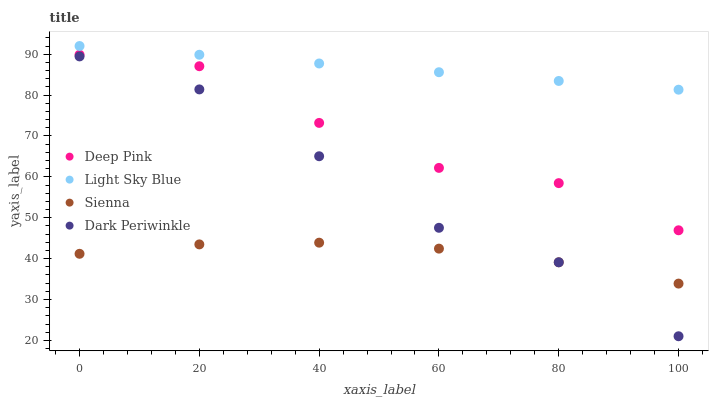Does Sienna have the minimum area under the curve?
Answer yes or no. Yes. Does Light Sky Blue have the maximum area under the curve?
Answer yes or no. Yes. Does Deep Pink have the minimum area under the curve?
Answer yes or no. No. Does Deep Pink have the maximum area under the curve?
Answer yes or no. No. Is Light Sky Blue the smoothest?
Answer yes or no. Yes. Is Deep Pink the roughest?
Answer yes or no. Yes. Is Dark Periwinkle the smoothest?
Answer yes or no. No. Is Dark Periwinkle the roughest?
Answer yes or no. No. Does Dark Periwinkle have the lowest value?
Answer yes or no. Yes. Does Deep Pink have the lowest value?
Answer yes or no. No. Does Light Sky Blue have the highest value?
Answer yes or no. Yes. Does Deep Pink have the highest value?
Answer yes or no. No. Is Sienna less than Deep Pink?
Answer yes or no. Yes. Is Deep Pink greater than Dark Periwinkle?
Answer yes or no. Yes. Does Dark Periwinkle intersect Sienna?
Answer yes or no. Yes. Is Dark Periwinkle less than Sienna?
Answer yes or no. No. Is Dark Periwinkle greater than Sienna?
Answer yes or no. No. Does Sienna intersect Deep Pink?
Answer yes or no. No. 